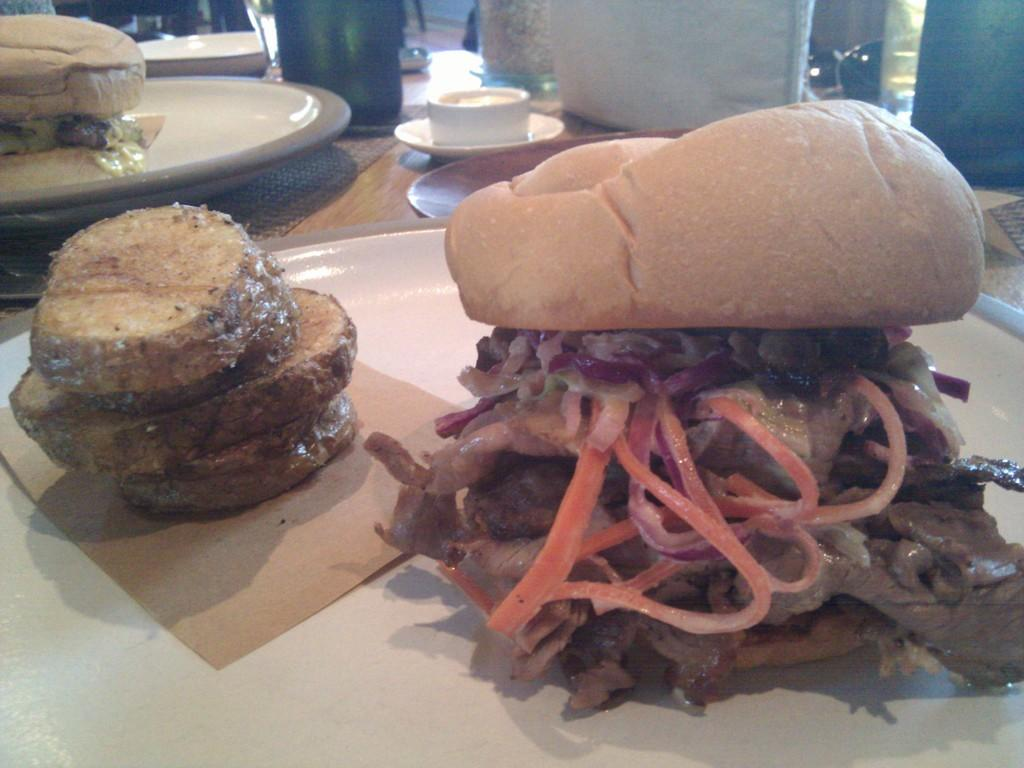What type of food item is on the plate in the image? There is a burger on the plate in the image. What is the liquid in the cup in the image? The information provided does not specify the type of liquid in the cup. What is the bottle in the image used for? The information provided does not specify the purpose of the bottle. What other objects can be seen on the table in the image? There are other objects on the table in the image, but their specific details are not mentioned. What type of bird is sitting on the son's shoulder in the image? There is no son or bird present in the image; it only features a burger on a plate, a cup with liquid, a bottle, and other objects on a table. 